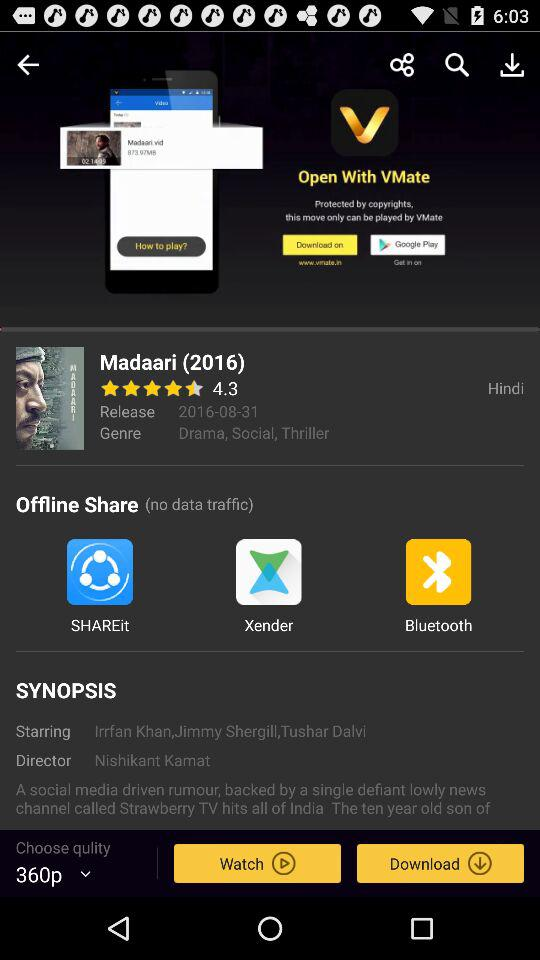What is the release date of the movie Madaari?
Answer the question using a single word or phrase. 2016-08-31 